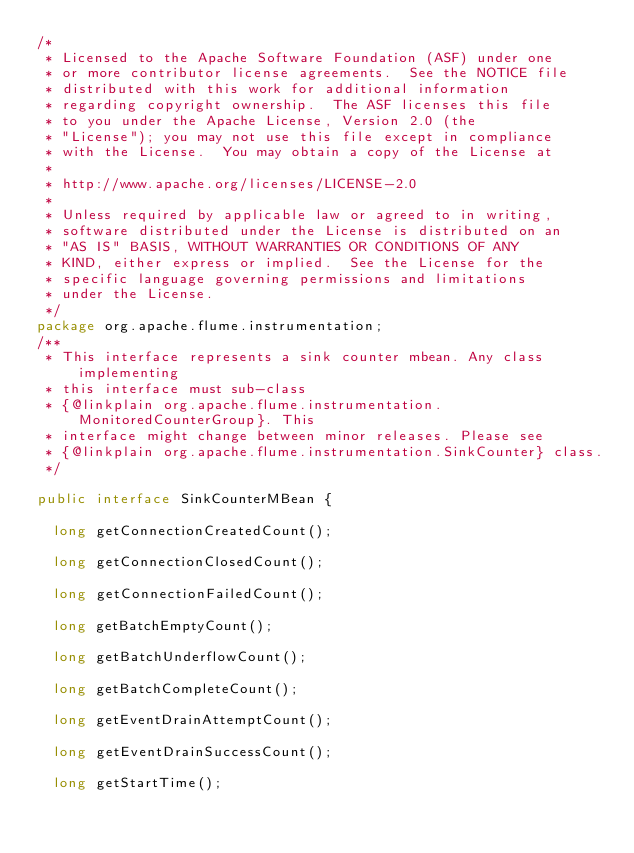Convert code to text. <code><loc_0><loc_0><loc_500><loc_500><_Java_>/*
 * Licensed to the Apache Software Foundation (ASF) under one
 * or more contributor license agreements.  See the NOTICE file
 * distributed with this work for additional information
 * regarding copyright ownership.  The ASF licenses this file
 * to you under the Apache License, Version 2.0 (the
 * "License"); you may not use this file except in compliance
 * with the License.  You may obtain a copy of the License at
 *
 * http://www.apache.org/licenses/LICENSE-2.0
 *
 * Unless required by applicable law or agreed to in writing,
 * software distributed under the License is distributed on an
 * "AS IS" BASIS, WITHOUT WARRANTIES OR CONDITIONS OF ANY
 * KIND, either express or implied.  See the License for the
 * specific language governing permissions and limitations
 * under the License.
 */
package org.apache.flume.instrumentation;
/**
 * This interface represents a sink counter mbean. Any class implementing
 * this interface must sub-class
 * {@linkplain org.apache.flume.instrumentation.MonitoredCounterGroup}. This
 * interface might change between minor releases. Please see
 * {@linkplain org.apache.flume.instrumentation.SinkCounter} class.
 */

public interface SinkCounterMBean {

  long getConnectionCreatedCount();

  long getConnectionClosedCount();

  long getConnectionFailedCount();

  long getBatchEmptyCount();

  long getBatchUnderflowCount();

  long getBatchCompleteCount();

  long getEventDrainAttemptCount();

  long getEventDrainSuccessCount();

  long getStartTime();
</code> 